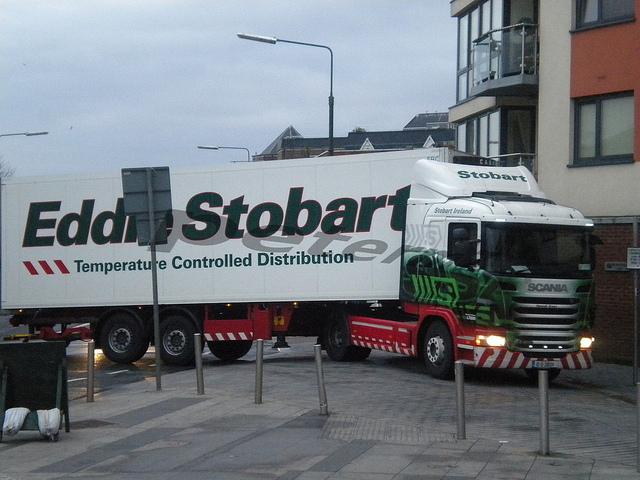Are these state police?
Concise answer only. No. What is parked behind the sign?
Write a very short answer. Truck. Where is the bus at?
Give a very brief answer. No bus. Is this truck in the crosswalk?
Be succinct. No. What is written on the front of the truck?
Short answer required. Stobart. How many "do not U turn" signs are there in this picture?
Give a very brief answer. 0. Is the writing in English?
Keep it brief. Yes. How many doors in this?
Be succinct. 1. Are there bicycles in the picture?
Give a very brief answer. No. Is there a balcony?
Keep it brief. Yes. Is this an English speaking country?
Short answer required. Yes. How many smoke stacks does the truck have?
Concise answer only. 0. Is the building made of brick?
Give a very brief answer. No. What is written on the truck?
Give a very brief answer. Eddie stobart. Is there a stop light?
Keep it brief. No. What happened to the truck?
Keep it brief. Turned. Are the cars parked parallel or diagonally?
Give a very brief answer. Diagonally. What color is the trailer?
Write a very short answer. White. What brand is the truck?
Short answer required. Eddie stobart. How big is the truck?
Write a very short answer. Large. What kind of vehicles are these?
Write a very short answer. Truck. What city was the photo taken in?
Write a very short answer. New york. Are there two or more double decker buses on the street?
Concise answer only. No. What decade was this picture taken?
Quick response, please. 2000. What type of truck is that?
Answer briefly. Semi. How many trailers are there?
Give a very brief answer. 1. Is there any street light?
Give a very brief answer. Yes. What is the language on the truck?
Short answer required. English. What color is the ad on the side of the truck?
Be succinct. Black. 